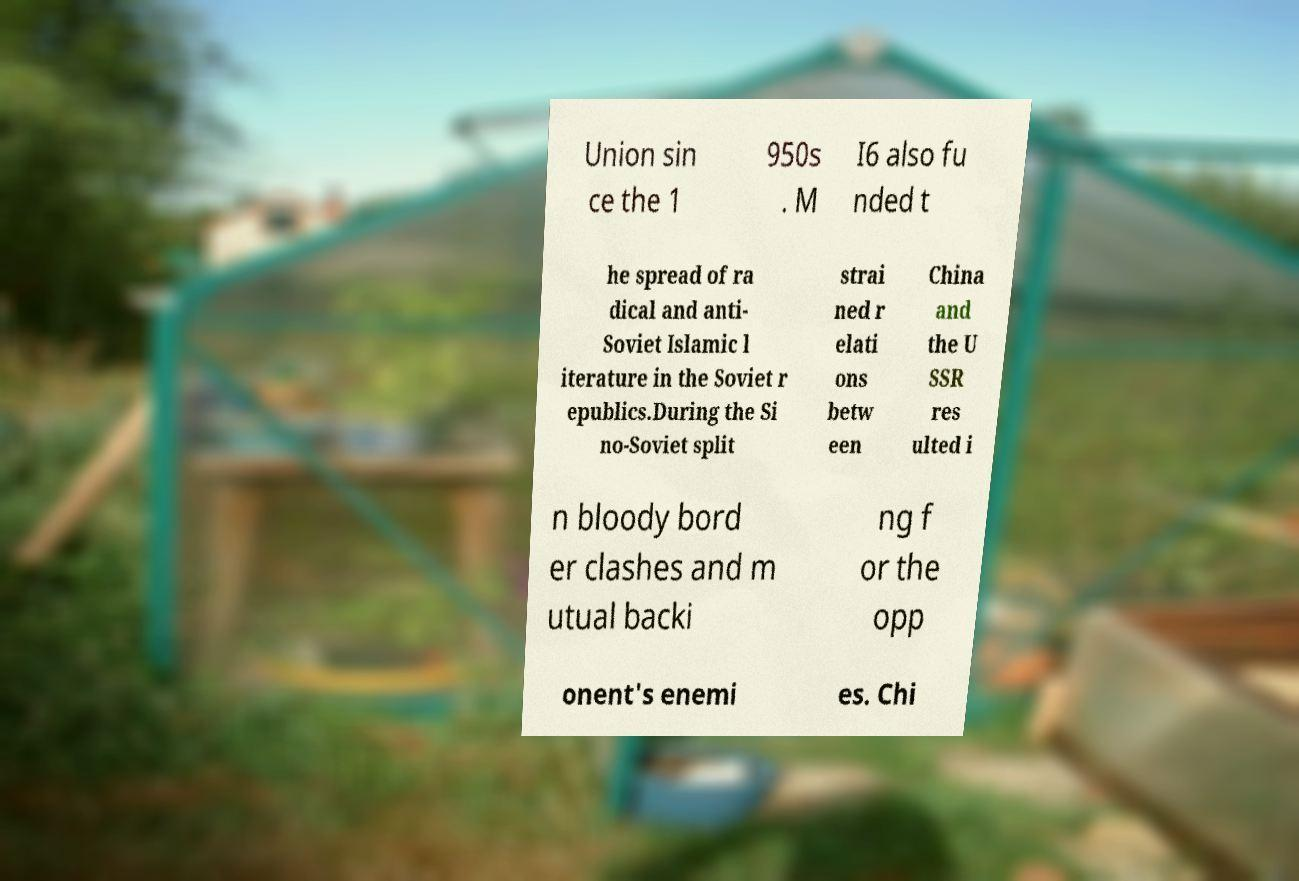Can you accurately transcribe the text from the provided image for me? Union sin ce the 1 950s . M I6 also fu nded t he spread of ra dical and anti- Soviet Islamic l iterature in the Soviet r epublics.During the Si no-Soviet split strai ned r elati ons betw een China and the U SSR res ulted i n bloody bord er clashes and m utual backi ng f or the opp onent's enemi es. Chi 